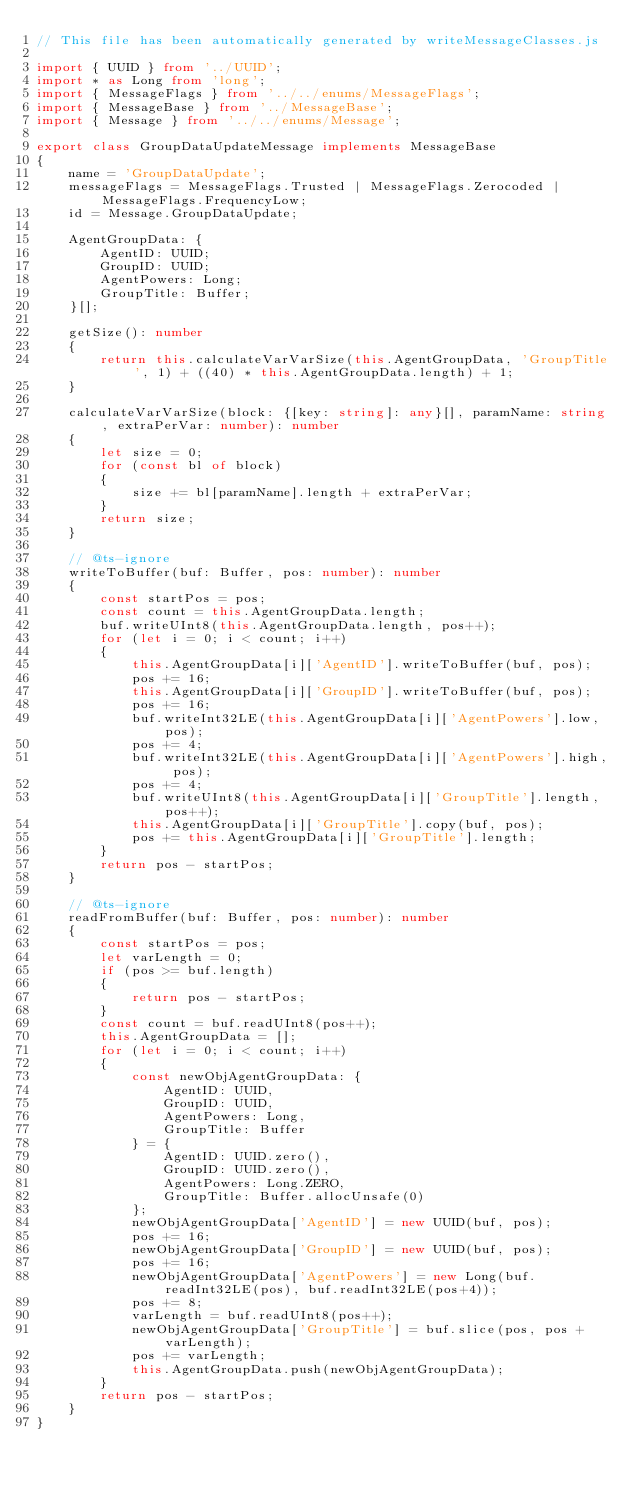Convert code to text. <code><loc_0><loc_0><loc_500><loc_500><_TypeScript_>// This file has been automatically generated by writeMessageClasses.js

import { UUID } from '../UUID';
import * as Long from 'long';
import { MessageFlags } from '../../enums/MessageFlags';
import { MessageBase } from '../MessageBase';
import { Message } from '../../enums/Message';

export class GroupDataUpdateMessage implements MessageBase
{
    name = 'GroupDataUpdate';
    messageFlags = MessageFlags.Trusted | MessageFlags.Zerocoded | MessageFlags.FrequencyLow;
    id = Message.GroupDataUpdate;

    AgentGroupData: {
        AgentID: UUID;
        GroupID: UUID;
        AgentPowers: Long;
        GroupTitle: Buffer;
    }[];

    getSize(): number
    {
        return this.calculateVarVarSize(this.AgentGroupData, 'GroupTitle', 1) + ((40) * this.AgentGroupData.length) + 1;
    }

    calculateVarVarSize(block: {[key: string]: any}[], paramName: string, extraPerVar: number): number
    {
        let size = 0;
        for (const bl of block)
        {
            size += bl[paramName].length + extraPerVar;
        }
        return size;
    }

    // @ts-ignore
    writeToBuffer(buf: Buffer, pos: number): number
    {
        const startPos = pos;
        const count = this.AgentGroupData.length;
        buf.writeUInt8(this.AgentGroupData.length, pos++);
        for (let i = 0; i < count; i++)
        {
            this.AgentGroupData[i]['AgentID'].writeToBuffer(buf, pos);
            pos += 16;
            this.AgentGroupData[i]['GroupID'].writeToBuffer(buf, pos);
            pos += 16;
            buf.writeInt32LE(this.AgentGroupData[i]['AgentPowers'].low, pos);
            pos += 4;
            buf.writeInt32LE(this.AgentGroupData[i]['AgentPowers'].high, pos);
            pos += 4;
            buf.writeUInt8(this.AgentGroupData[i]['GroupTitle'].length, pos++);
            this.AgentGroupData[i]['GroupTitle'].copy(buf, pos);
            pos += this.AgentGroupData[i]['GroupTitle'].length;
        }
        return pos - startPos;
    }

    // @ts-ignore
    readFromBuffer(buf: Buffer, pos: number): number
    {
        const startPos = pos;
        let varLength = 0;
        if (pos >= buf.length)
        {
            return pos - startPos;
        }
        const count = buf.readUInt8(pos++);
        this.AgentGroupData = [];
        for (let i = 0; i < count; i++)
        {
            const newObjAgentGroupData: {
                AgentID: UUID,
                GroupID: UUID,
                AgentPowers: Long,
                GroupTitle: Buffer
            } = {
                AgentID: UUID.zero(),
                GroupID: UUID.zero(),
                AgentPowers: Long.ZERO,
                GroupTitle: Buffer.allocUnsafe(0)
            };
            newObjAgentGroupData['AgentID'] = new UUID(buf, pos);
            pos += 16;
            newObjAgentGroupData['GroupID'] = new UUID(buf, pos);
            pos += 16;
            newObjAgentGroupData['AgentPowers'] = new Long(buf.readInt32LE(pos), buf.readInt32LE(pos+4));
            pos += 8;
            varLength = buf.readUInt8(pos++);
            newObjAgentGroupData['GroupTitle'] = buf.slice(pos, pos + varLength);
            pos += varLength;
            this.AgentGroupData.push(newObjAgentGroupData);
        }
        return pos - startPos;
    }
}

</code> 